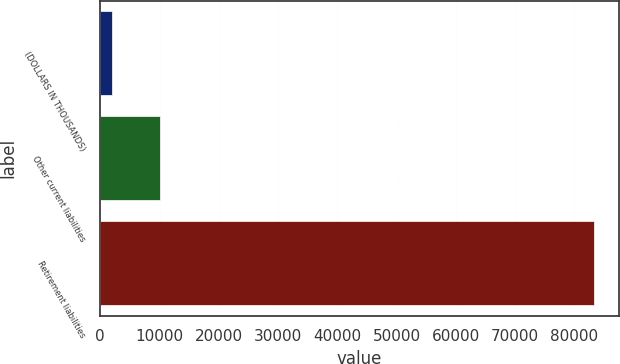Convert chart to OTSL. <chart><loc_0><loc_0><loc_500><loc_500><bar_chart><fcel>(DOLLARS IN THOUSANDS)<fcel>Other current liabilities<fcel>Retirement liabilities<nl><fcel>2015<fcel>10146.9<fcel>83334<nl></chart> 